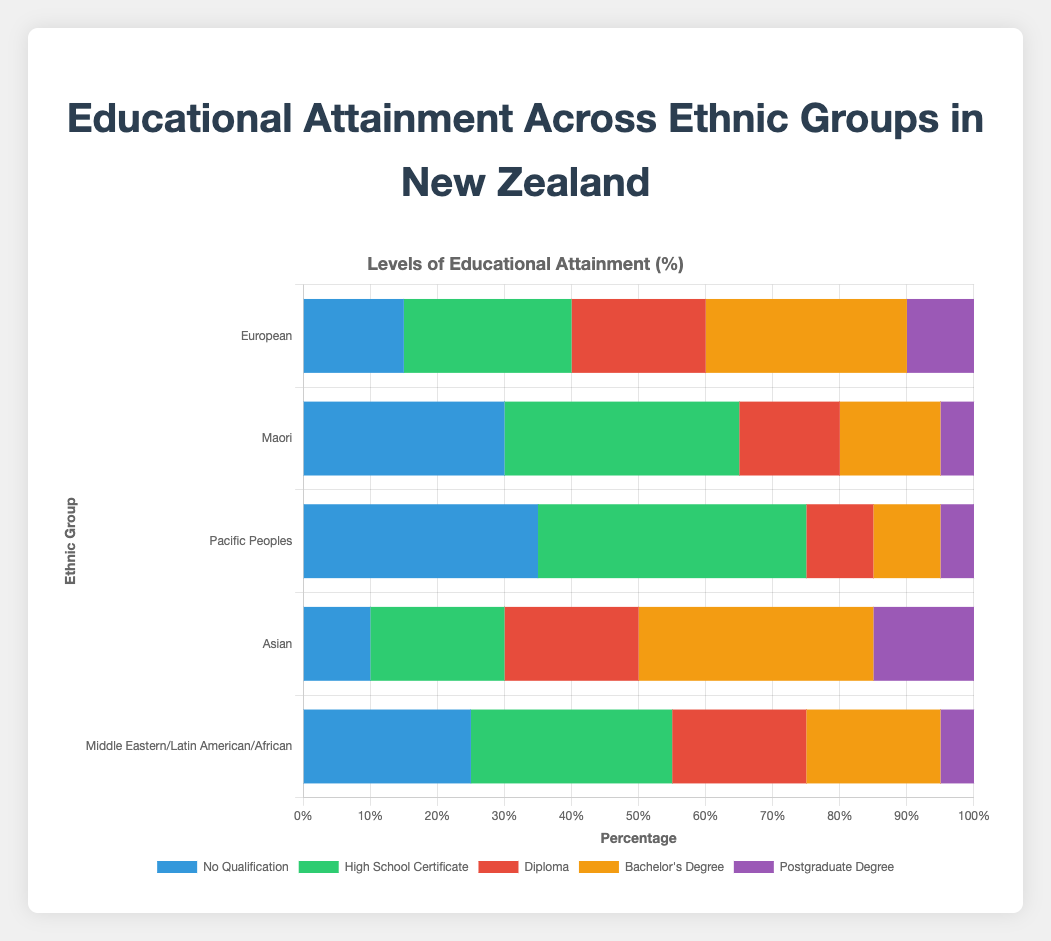Which ethnic group has the highest percentage of people with no qualifications? Look at the "No Qualification" category and identify the ethnic group with the tallest bar. The Pacific Peoples have the tallest bar in this category.
Answer: Pacific Peoples Which ethnic group has the lowest percentage of people with bachelor's degrees? Look at the "Bachelor's Degree" category and identify the ethnic group with the shortest bar. Both Maori and Pacific Peoples have the shortest bars in this category.
Answer: Maori and Pacific Peoples What's the total percentage of people with a high school certificate and diploma in the European group? Add the percentage values for "High School Certificate" and "Diploma" in the European group: 25 + 20 = 45.
Answer: 45% How does the percentage of postgraduate degrees in the Asian group compare to the European group? Compare the lengths of the bars for the "Postgraduate Degree" category between the Asian and European groups. The Asian group (15%) has a higher percentage than the European group (10%).
Answer: Asian group is higher Which group has the greatest discrepancy between the percentage of people with no qualifications and those with a bachelor's degree? Subtract the percentage of "Bachelor's Degree" from "No Qualification" for each group and find the maximum difference. Maximum difference: Pacific Peoples (35 - 10 = 25).
Answer: Pacific Peoples Arrange the ethnic groups in descending order based on the percentage of people with high school certificates. Order the lengths of the bars in the "High School Certificate" category: Pacific Peoples (40), Maori (35), Middle Eastern/Latin American/African (30), European (25), Asian (20).
Answer: Pacific Peoples, Maori, Middle Eastern/Latin American/African, European, Asian Combine the percentage of people with diplomas and postgraduate degrees in the Maori group. Sum the percentage values for "Diploma" and "Postgraduate Degree" in the Maori group: 15 + 5 = 20.
Answer: 20% Which ethnic group has the most balanced distribution across all educational levels? Examine the lengths of the bars for each ethnic group to identify the one with more similar bar lengths across categories. The European group has a more balanced distribution across different education levels.
Answer: European Calculate the average percentage of bachelor's degree attainment across all ethnic groups. Sum the percentages of "Bachelor's Degree" for all groups and divide by the number of groups: (30 + 15 + 10 + 35 + 20) / 5 = 110 / 5 = 22.
Answer: 22% What's the difference in the percentage of people with postgraduate degrees between the Asian and Maori groups? Subtract the percentage of "Postgraduate Degree" in the Maori group from that in the Asian group: 15 - 5 = 10.
Answer: 10 